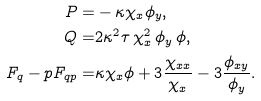Convert formula to latex. <formula><loc_0><loc_0><loc_500><loc_500>P = & - \kappa \chi _ { x } \phi _ { y } , \\ Q = & 2 \kappa ^ { 2 } \tau \, \chi _ { x } ^ { 2 } \, \phi _ { y } \, \phi , \\ F _ { q } - p F _ { q p } = & \kappa \chi _ { x } \phi + 3 \frac { \chi _ { x x } } { \chi _ { x } } - 3 \frac { \phi _ { x y } } { \phi _ { y } } .</formula> 